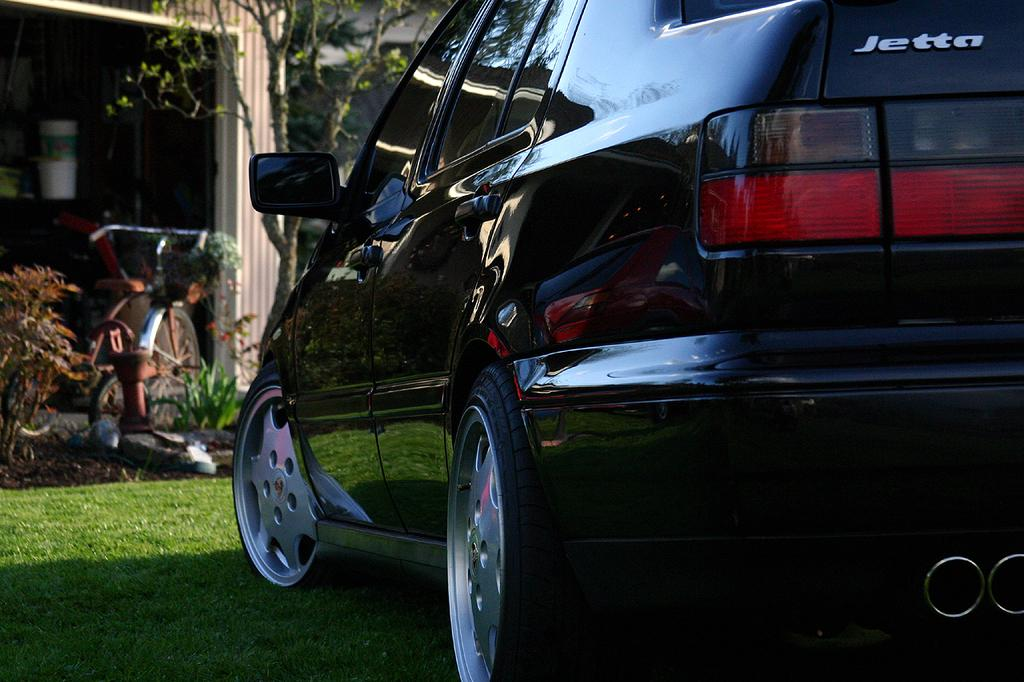What is the main subject in the center of the image? There is a car in the center of the image. What can be seen in the background of the image? There are trees, plants, a shed, and buckets in the background of the image. What other mode of transportation is visible in the image? There is a bicycle in the image. What is the surface on which the car and bicycle are placed? There is a ground at the bottom of the image. How many dogs are present in the image, and what are they trading? There are no dogs present in the image, and therefore no trading can be observed. 